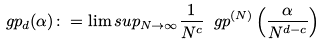Convert formula to latex. <formula><loc_0><loc_0><loc_500><loc_500>\ g p _ { d } ( \alpha ) \colon = \lim s u p _ { N \to \infty } \frac { 1 } { N ^ { c } } \ g p ^ { ( N ) } \left ( \frac { \alpha } { N ^ { d - c } } \right )</formula> 